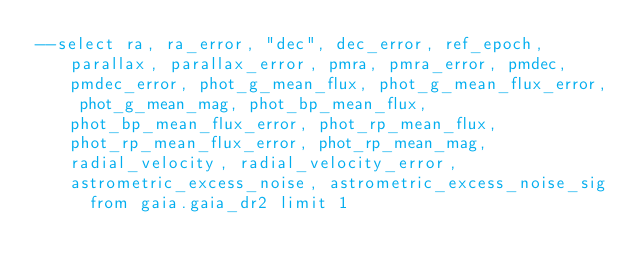Convert code to text. <code><loc_0><loc_0><loc_500><loc_500><_SQL_>--select ra, ra_error, "dec", dec_error, ref_epoch, parallax, parallax_error, pmra, pmra_error, pmdec, pmdec_error, phot_g_mean_flux, phot_g_mean_flux_error, phot_g_mean_mag, phot_bp_mean_flux, phot_bp_mean_flux_error, phot_rp_mean_flux, phot_rp_mean_flux_error, phot_rp_mean_mag, radial_velocity, radial_velocity_error, astrometric_excess_noise, astrometric_excess_noise_sig  from gaia.gaia_dr2 limit 1
</code> 